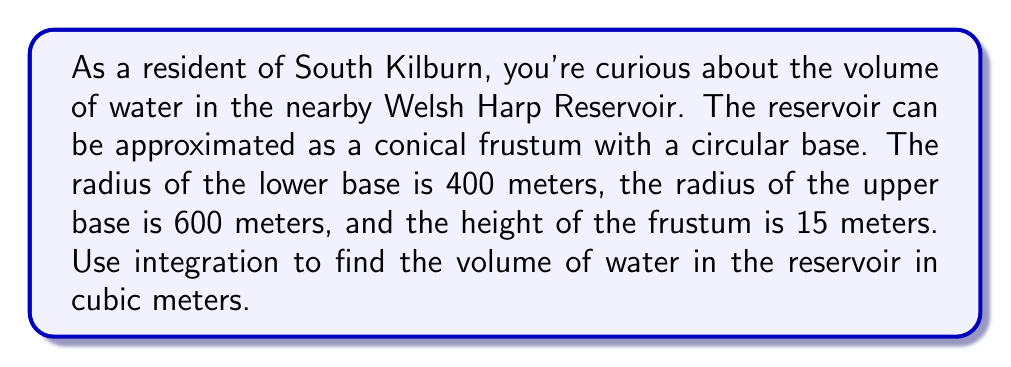Show me your answer to this math problem. To solve this problem, we'll use the washer method of integration. Here's the step-by-step approach:

1) First, we need to set up our coordinate system. Let's place the origin at the center of the lower base, with the z-axis pointing upwards.

2) We need to find the equation of the line that forms the side of the frustum. We can do this using the two-point form:

   $\frac{r - 400}{z} = \frac{600 - 400}{15}$

   Simplifying: $r = 400 + \frac{200z}{15} = 400 + \frac{40z}{3}$

3) Now we can set up our integral. The volume of a washer is given by:

   $V = \pi \int_a^b [R(z)^2 - r(z)^2] dz$

   Where $R(z)$ is the outer radius and $r(z)$ is the inner radius at height z.

4) In our case:
   $R(z) = 400 + \frac{40z}{3}$
   $r(z) = 0$ (since we're finding the total volume)
   $a = 0$ and $b = 15$ (the height limits)

5) Substituting into our integral:

   $V = \pi \int_0^{15} [(400 + \frac{40z}{3})^2 - 0^2] dz$

6) Expanding the squared term:

   $V = \pi \int_0^{15} [160000 + \frac{32000z}{3} + \frac{1600z^2}{9}] dz$

7) Integrating:

   $V = \pi [160000z + \frac{16000z^2}{3} + \frac{1600z^3}{27}]_0^{15}$

8) Evaluating at the limits:

   $V = \pi [(2400000 + 1200000 + 200000) - (0 + 0 + 0)]$
   $V = 3800000\pi$

9) Converting to cubic meters:

   $V = 3800000\pi \approx 11,938,052.08$ cubic meters
Answer: The volume of water in the Welsh Harp Reservoir is approximately 11,938,052 cubic meters. 